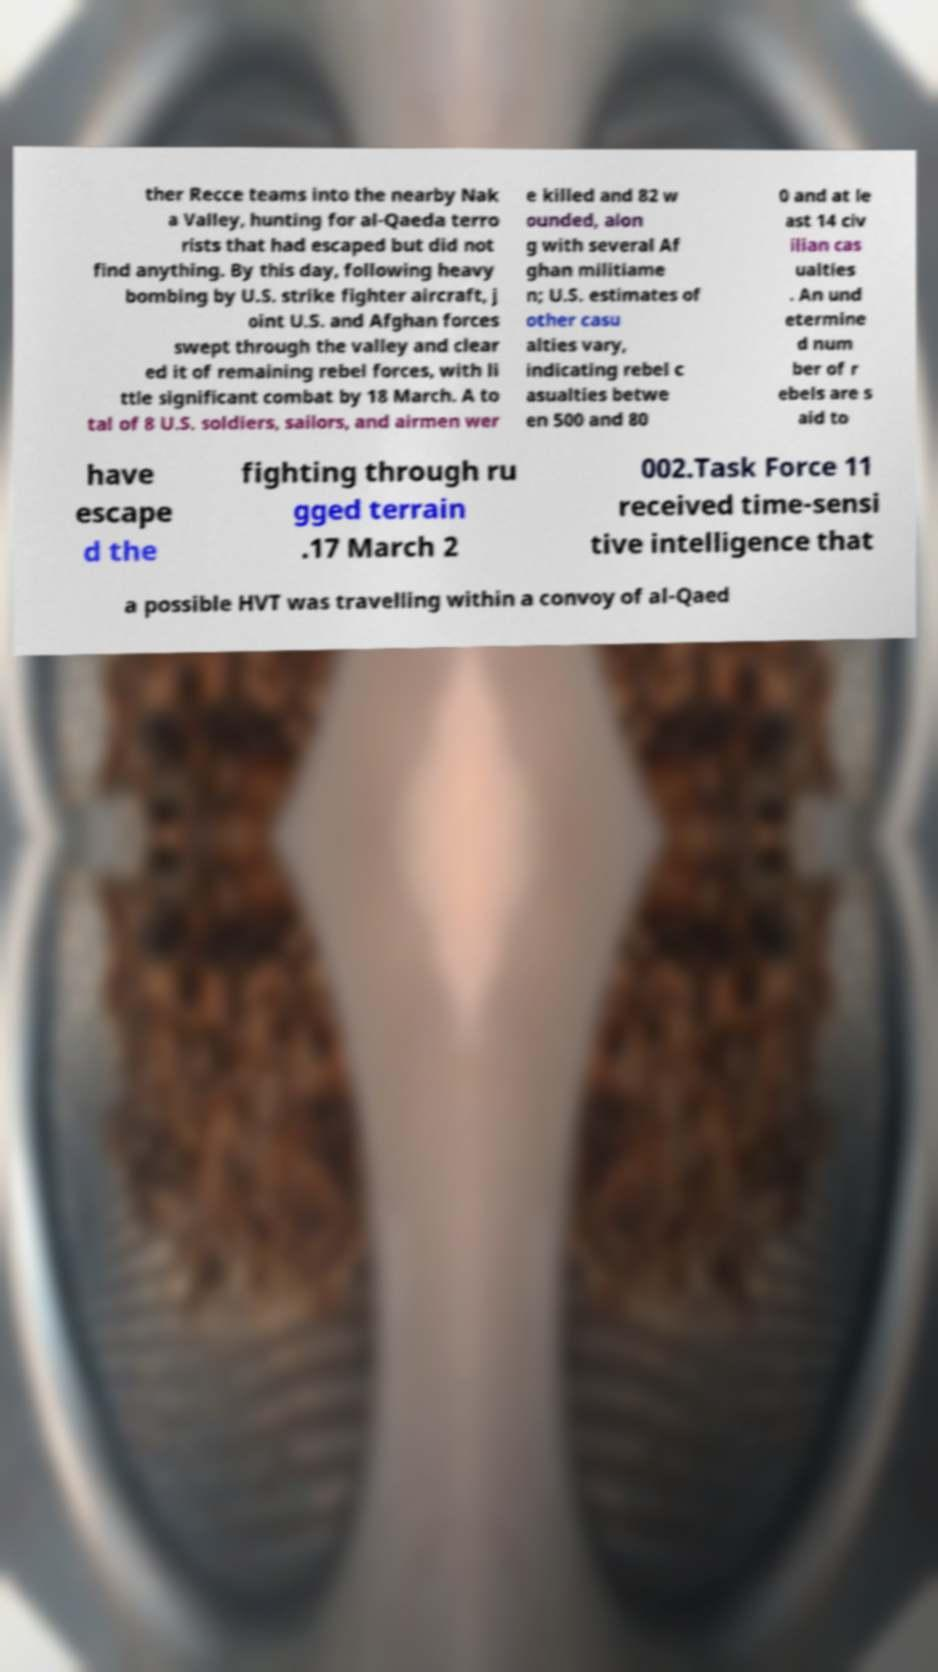Please identify and transcribe the text found in this image. ther Recce teams into the nearby Nak a Valley, hunting for al-Qaeda terro rists that had escaped but did not find anything. By this day, following heavy bombing by U.S. strike fighter aircraft, j oint U.S. and Afghan forces swept through the valley and clear ed it of remaining rebel forces, with li ttle significant combat by 18 March. A to tal of 8 U.S. soldiers, sailors, and airmen wer e killed and 82 w ounded, alon g with several Af ghan militiame n; U.S. estimates of other casu alties vary, indicating rebel c asualties betwe en 500 and 80 0 and at le ast 14 civ ilian cas ualties . An und etermine d num ber of r ebels are s aid to have escape d the fighting through ru gged terrain .17 March 2 002.Task Force 11 received time-sensi tive intelligence that a possible HVT was travelling within a convoy of al-Qaed 